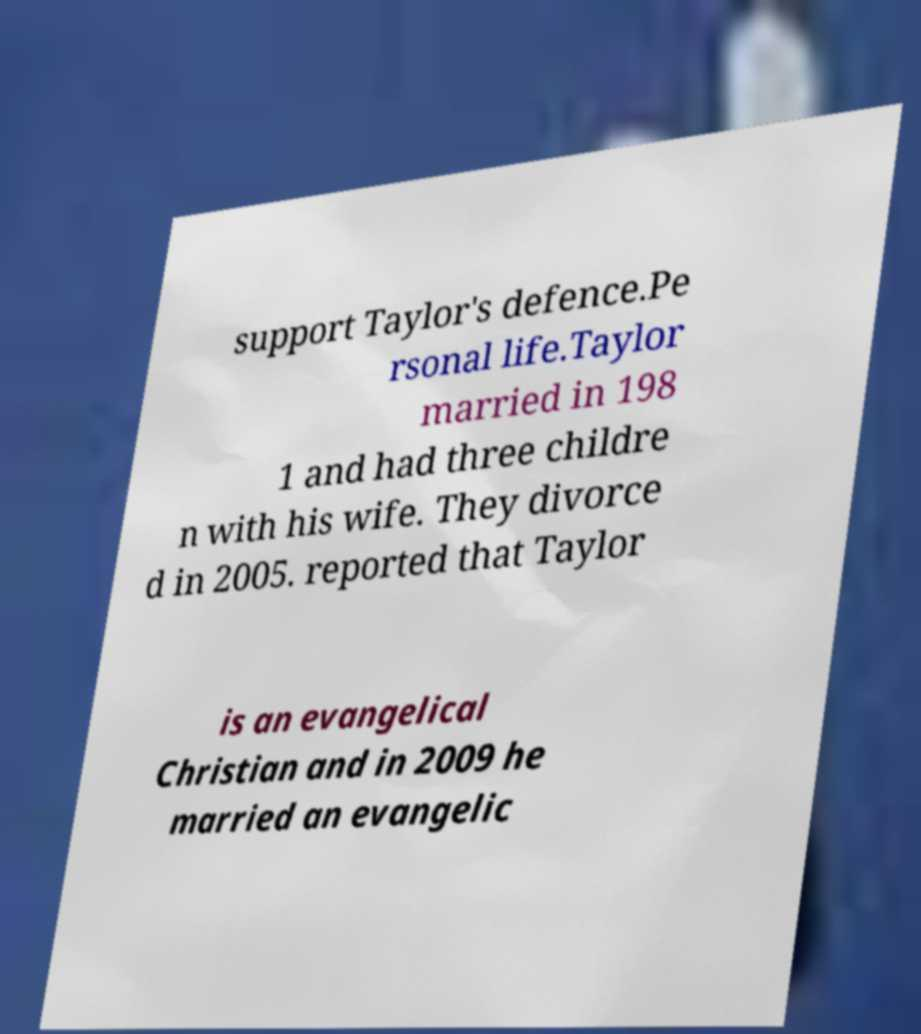There's text embedded in this image that I need extracted. Can you transcribe it verbatim? support Taylor's defence.Pe rsonal life.Taylor married in 198 1 and had three childre n with his wife. They divorce d in 2005. reported that Taylor is an evangelical Christian and in 2009 he married an evangelic 